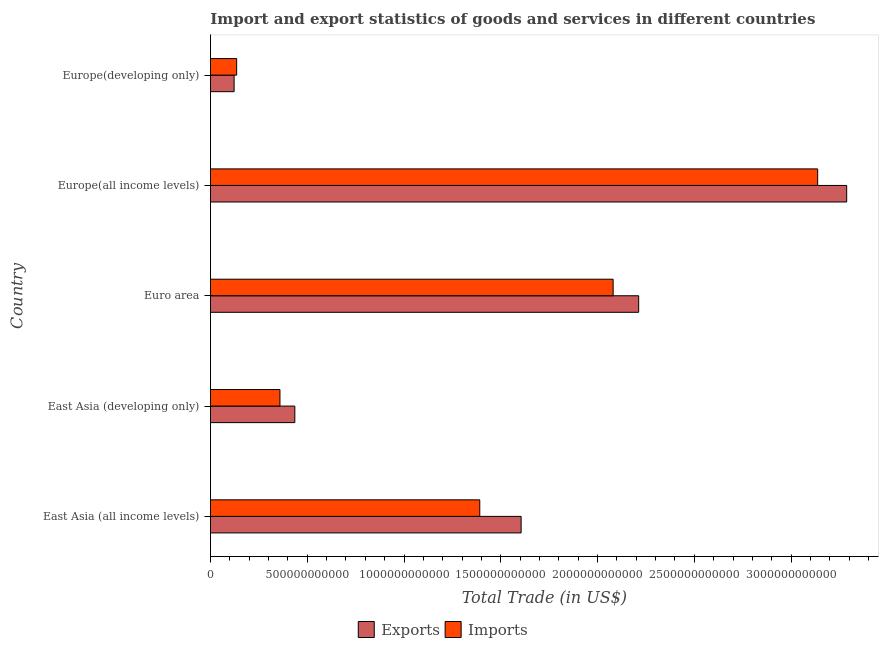How many groups of bars are there?
Your answer should be very brief. 5. What is the label of the 1st group of bars from the top?
Provide a succinct answer. Europe(developing only). What is the export of goods and services in East Asia (developing only)?
Give a very brief answer. 4.36e+11. Across all countries, what is the maximum export of goods and services?
Your answer should be compact. 3.29e+12. Across all countries, what is the minimum imports of goods and services?
Give a very brief answer. 1.35e+11. In which country was the export of goods and services maximum?
Offer a very short reply. Europe(all income levels). In which country was the export of goods and services minimum?
Your answer should be compact. Europe(developing only). What is the total export of goods and services in the graph?
Your answer should be very brief. 7.66e+12. What is the difference between the imports of goods and services in East Asia (all income levels) and that in Euro area?
Make the answer very short. -6.89e+11. What is the difference between the imports of goods and services in Europe(all income levels) and the export of goods and services in East Asia (developing only)?
Provide a short and direct response. 2.70e+12. What is the average export of goods and services per country?
Give a very brief answer. 1.53e+12. What is the difference between the export of goods and services and imports of goods and services in East Asia (all income levels)?
Provide a succinct answer. 2.14e+11. In how many countries, is the export of goods and services greater than 2000000000000 US$?
Your answer should be compact. 2. What is the ratio of the export of goods and services in East Asia (developing only) to that in Europe(developing only)?
Give a very brief answer. 3.57. Is the export of goods and services in East Asia (developing only) less than that in Euro area?
Offer a terse response. Yes. Is the difference between the export of goods and services in Europe(all income levels) and Europe(developing only) greater than the difference between the imports of goods and services in Europe(all income levels) and Europe(developing only)?
Make the answer very short. Yes. What is the difference between the highest and the second highest export of goods and services?
Give a very brief answer. 1.07e+12. What is the difference between the highest and the lowest imports of goods and services?
Keep it short and to the point. 3.00e+12. In how many countries, is the imports of goods and services greater than the average imports of goods and services taken over all countries?
Provide a short and direct response. 2. What does the 2nd bar from the top in East Asia (all income levels) represents?
Offer a terse response. Exports. What does the 1st bar from the bottom in Europe(developing only) represents?
Your response must be concise. Exports. What is the difference between two consecutive major ticks on the X-axis?
Your answer should be very brief. 5.00e+11. Does the graph contain any zero values?
Keep it short and to the point. No. What is the title of the graph?
Your answer should be compact. Import and export statistics of goods and services in different countries. Does "Lower secondary rate" appear as one of the legend labels in the graph?
Ensure brevity in your answer.  No. What is the label or title of the X-axis?
Ensure brevity in your answer.  Total Trade (in US$). What is the label or title of the Y-axis?
Provide a short and direct response. Country. What is the Total Trade (in US$) in Exports in East Asia (all income levels)?
Ensure brevity in your answer.  1.61e+12. What is the Total Trade (in US$) in Imports in East Asia (all income levels)?
Provide a succinct answer. 1.39e+12. What is the Total Trade (in US$) in Exports in East Asia (developing only)?
Keep it short and to the point. 4.36e+11. What is the Total Trade (in US$) in Imports in East Asia (developing only)?
Offer a terse response. 3.59e+11. What is the Total Trade (in US$) of Exports in Euro area?
Offer a terse response. 2.21e+12. What is the Total Trade (in US$) of Imports in Euro area?
Provide a succinct answer. 2.08e+12. What is the Total Trade (in US$) of Exports in Europe(all income levels)?
Keep it short and to the point. 3.29e+12. What is the Total Trade (in US$) in Imports in Europe(all income levels)?
Your response must be concise. 3.14e+12. What is the Total Trade (in US$) in Exports in Europe(developing only)?
Ensure brevity in your answer.  1.22e+11. What is the Total Trade (in US$) in Imports in Europe(developing only)?
Keep it short and to the point. 1.35e+11. Across all countries, what is the maximum Total Trade (in US$) in Exports?
Offer a very short reply. 3.29e+12. Across all countries, what is the maximum Total Trade (in US$) of Imports?
Ensure brevity in your answer.  3.14e+12. Across all countries, what is the minimum Total Trade (in US$) of Exports?
Make the answer very short. 1.22e+11. Across all countries, what is the minimum Total Trade (in US$) in Imports?
Offer a very short reply. 1.35e+11. What is the total Total Trade (in US$) in Exports in the graph?
Provide a short and direct response. 7.66e+12. What is the total Total Trade (in US$) of Imports in the graph?
Provide a short and direct response. 7.10e+12. What is the difference between the Total Trade (in US$) in Exports in East Asia (all income levels) and that in East Asia (developing only)?
Ensure brevity in your answer.  1.17e+12. What is the difference between the Total Trade (in US$) of Imports in East Asia (all income levels) and that in East Asia (developing only)?
Give a very brief answer. 1.03e+12. What is the difference between the Total Trade (in US$) in Exports in East Asia (all income levels) and that in Euro area?
Your answer should be very brief. -6.07e+11. What is the difference between the Total Trade (in US$) in Imports in East Asia (all income levels) and that in Euro area?
Provide a short and direct response. -6.89e+11. What is the difference between the Total Trade (in US$) in Exports in East Asia (all income levels) and that in Europe(all income levels)?
Give a very brief answer. -1.68e+12. What is the difference between the Total Trade (in US$) in Imports in East Asia (all income levels) and that in Europe(all income levels)?
Offer a terse response. -1.75e+12. What is the difference between the Total Trade (in US$) in Exports in East Asia (all income levels) and that in Europe(developing only)?
Your answer should be very brief. 1.48e+12. What is the difference between the Total Trade (in US$) of Imports in East Asia (all income levels) and that in Europe(developing only)?
Your response must be concise. 1.26e+12. What is the difference between the Total Trade (in US$) in Exports in East Asia (developing only) and that in Euro area?
Ensure brevity in your answer.  -1.78e+12. What is the difference between the Total Trade (in US$) in Imports in East Asia (developing only) and that in Euro area?
Provide a succinct answer. -1.72e+12. What is the difference between the Total Trade (in US$) in Exports in East Asia (developing only) and that in Europe(all income levels)?
Ensure brevity in your answer.  -2.85e+12. What is the difference between the Total Trade (in US$) in Imports in East Asia (developing only) and that in Europe(all income levels)?
Ensure brevity in your answer.  -2.78e+12. What is the difference between the Total Trade (in US$) of Exports in East Asia (developing only) and that in Europe(developing only)?
Your response must be concise. 3.14e+11. What is the difference between the Total Trade (in US$) of Imports in East Asia (developing only) and that in Europe(developing only)?
Provide a short and direct response. 2.24e+11. What is the difference between the Total Trade (in US$) in Exports in Euro area and that in Europe(all income levels)?
Your answer should be compact. -1.07e+12. What is the difference between the Total Trade (in US$) in Imports in Euro area and that in Europe(all income levels)?
Your answer should be very brief. -1.06e+12. What is the difference between the Total Trade (in US$) in Exports in Euro area and that in Europe(developing only)?
Provide a succinct answer. 2.09e+12. What is the difference between the Total Trade (in US$) of Imports in Euro area and that in Europe(developing only)?
Make the answer very short. 1.95e+12. What is the difference between the Total Trade (in US$) in Exports in Europe(all income levels) and that in Europe(developing only)?
Offer a very short reply. 3.17e+12. What is the difference between the Total Trade (in US$) in Imports in Europe(all income levels) and that in Europe(developing only)?
Provide a succinct answer. 3.00e+12. What is the difference between the Total Trade (in US$) in Exports in East Asia (all income levels) and the Total Trade (in US$) in Imports in East Asia (developing only)?
Ensure brevity in your answer.  1.25e+12. What is the difference between the Total Trade (in US$) in Exports in East Asia (all income levels) and the Total Trade (in US$) in Imports in Euro area?
Provide a succinct answer. -4.75e+11. What is the difference between the Total Trade (in US$) of Exports in East Asia (all income levels) and the Total Trade (in US$) of Imports in Europe(all income levels)?
Ensure brevity in your answer.  -1.53e+12. What is the difference between the Total Trade (in US$) of Exports in East Asia (all income levels) and the Total Trade (in US$) of Imports in Europe(developing only)?
Your answer should be compact. 1.47e+12. What is the difference between the Total Trade (in US$) of Exports in East Asia (developing only) and the Total Trade (in US$) of Imports in Euro area?
Offer a terse response. -1.64e+12. What is the difference between the Total Trade (in US$) in Exports in East Asia (developing only) and the Total Trade (in US$) in Imports in Europe(all income levels)?
Provide a short and direct response. -2.70e+12. What is the difference between the Total Trade (in US$) of Exports in East Asia (developing only) and the Total Trade (in US$) of Imports in Europe(developing only)?
Your answer should be compact. 3.01e+11. What is the difference between the Total Trade (in US$) of Exports in Euro area and the Total Trade (in US$) of Imports in Europe(all income levels)?
Give a very brief answer. -9.25e+11. What is the difference between the Total Trade (in US$) in Exports in Euro area and the Total Trade (in US$) in Imports in Europe(developing only)?
Provide a succinct answer. 2.08e+12. What is the difference between the Total Trade (in US$) of Exports in Europe(all income levels) and the Total Trade (in US$) of Imports in Europe(developing only)?
Make the answer very short. 3.15e+12. What is the average Total Trade (in US$) in Exports per country?
Your response must be concise. 1.53e+12. What is the average Total Trade (in US$) in Imports per country?
Offer a terse response. 1.42e+12. What is the difference between the Total Trade (in US$) of Exports and Total Trade (in US$) of Imports in East Asia (all income levels)?
Make the answer very short. 2.14e+11. What is the difference between the Total Trade (in US$) in Exports and Total Trade (in US$) in Imports in East Asia (developing only)?
Offer a terse response. 7.69e+1. What is the difference between the Total Trade (in US$) in Exports and Total Trade (in US$) in Imports in Euro area?
Your answer should be very brief. 1.32e+11. What is the difference between the Total Trade (in US$) in Exports and Total Trade (in US$) in Imports in Europe(all income levels)?
Ensure brevity in your answer.  1.50e+11. What is the difference between the Total Trade (in US$) of Exports and Total Trade (in US$) of Imports in Europe(developing only)?
Your answer should be compact. -1.32e+1. What is the ratio of the Total Trade (in US$) of Exports in East Asia (all income levels) to that in East Asia (developing only)?
Provide a succinct answer. 3.68. What is the ratio of the Total Trade (in US$) in Imports in East Asia (all income levels) to that in East Asia (developing only)?
Ensure brevity in your answer.  3.88. What is the ratio of the Total Trade (in US$) in Exports in East Asia (all income levels) to that in Euro area?
Your answer should be very brief. 0.73. What is the ratio of the Total Trade (in US$) of Imports in East Asia (all income levels) to that in Euro area?
Keep it short and to the point. 0.67. What is the ratio of the Total Trade (in US$) in Exports in East Asia (all income levels) to that in Europe(all income levels)?
Offer a very short reply. 0.49. What is the ratio of the Total Trade (in US$) of Imports in East Asia (all income levels) to that in Europe(all income levels)?
Ensure brevity in your answer.  0.44. What is the ratio of the Total Trade (in US$) in Exports in East Asia (all income levels) to that in Europe(developing only)?
Give a very brief answer. 13.15. What is the ratio of the Total Trade (in US$) in Imports in East Asia (all income levels) to that in Europe(developing only)?
Your response must be concise. 10.28. What is the ratio of the Total Trade (in US$) in Exports in East Asia (developing only) to that in Euro area?
Your answer should be compact. 0.2. What is the ratio of the Total Trade (in US$) in Imports in East Asia (developing only) to that in Euro area?
Your answer should be compact. 0.17. What is the ratio of the Total Trade (in US$) of Exports in East Asia (developing only) to that in Europe(all income levels)?
Your answer should be compact. 0.13. What is the ratio of the Total Trade (in US$) in Imports in East Asia (developing only) to that in Europe(all income levels)?
Give a very brief answer. 0.11. What is the ratio of the Total Trade (in US$) in Exports in East Asia (developing only) to that in Europe(developing only)?
Offer a very short reply. 3.57. What is the ratio of the Total Trade (in US$) of Imports in East Asia (developing only) to that in Europe(developing only)?
Offer a terse response. 2.65. What is the ratio of the Total Trade (in US$) in Exports in Euro area to that in Europe(all income levels)?
Provide a short and direct response. 0.67. What is the ratio of the Total Trade (in US$) in Imports in Euro area to that in Europe(all income levels)?
Your response must be concise. 0.66. What is the ratio of the Total Trade (in US$) of Exports in Euro area to that in Europe(developing only)?
Offer a very short reply. 18.12. What is the ratio of the Total Trade (in US$) in Imports in Euro area to that in Europe(developing only)?
Give a very brief answer. 15.38. What is the ratio of the Total Trade (in US$) of Exports in Europe(all income levels) to that in Europe(developing only)?
Provide a succinct answer. 26.92. What is the ratio of the Total Trade (in US$) of Imports in Europe(all income levels) to that in Europe(developing only)?
Keep it short and to the point. 23.19. What is the difference between the highest and the second highest Total Trade (in US$) of Exports?
Offer a terse response. 1.07e+12. What is the difference between the highest and the second highest Total Trade (in US$) in Imports?
Keep it short and to the point. 1.06e+12. What is the difference between the highest and the lowest Total Trade (in US$) of Exports?
Offer a terse response. 3.17e+12. What is the difference between the highest and the lowest Total Trade (in US$) in Imports?
Your answer should be very brief. 3.00e+12. 